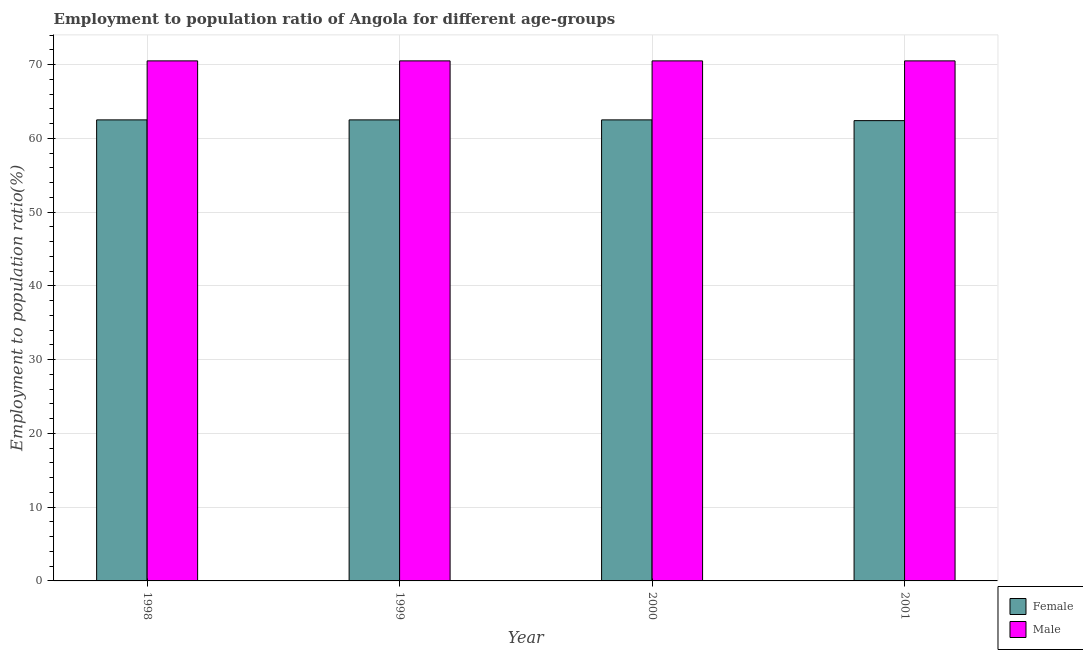How many different coloured bars are there?
Your response must be concise. 2. Are the number of bars per tick equal to the number of legend labels?
Ensure brevity in your answer.  Yes. Are the number of bars on each tick of the X-axis equal?
Your answer should be compact. Yes. How many bars are there on the 1st tick from the left?
Offer a very short reply. 2. What is the employment to population ratio(female) in 1998?
Provide a short and direct response. 62.5. Across all years, what is the maximum employment to population ratio(male)?
Ensure brevity in your answer.  70.5. Across all years, what is the minimum employment to population ratio(female)?
Keep it short and to the point. 62.4. In which year was the employment to population ratio(male) maximum?
Ensure brevity in your answer.  1998. In which year was the employment to population ratio(female) minimum?
Keep it short and to the point. 2001. What is the total employment to population ratio(male) in the graph?
Keep it short and to the point. 282. What is the difference between the employment to population ratio(female) in 1998 and that in 2001?
Provide a short and direct response. 0.1. What is the difference between the employment to population ratio(male) in 1998 and the employment to population ratio(female) in 2000?
Provide a short and direct response. 0. What is the average employment to population ratio(female) per year?
Offer a very short reply. 62.48. What is the ratio of the employment to population ratio(male) in 2000 to that in 2001?
Offer a very short reply. 1. Is the employment to population ratio(male) in 1998 less than that in 2000?
Provide a succinct answer. No. Is the difference between the employment to population ratio(male) in 1998 and 2000 greater than the difference between the employment to population ratio(female) in 1998 and 2000?
Keep it short and to the point. No. In how many years, is the employment to population ratio(female) greater than the average employment to population ratio(female) taken over all years?
Provide a short and direct response. 3. How many bars are there?
Keep it short and to the point. 8. How many years are there in the graph?
Your response must be concise. 4. Does the graph contain grids?
Your response must be concise. Yes. How many legend labels are there?
Give a very brief answer. 2. What is the title of the graph?
Your answer should be compact. Employment to population ratio of Angola for different age-groups. What is the Employment to population ratio(%) of Female in 1998?
Ensure brevity in your answer.  62.5. What is the Employment to population ratio(%) of Male in 1998?
Provide a short and direct response. 70.5. What is the Employment to population ratio(%) of Female in 1999?
Make the answer very short. 62.5. What is the Employment to population ratio(%) in Male in 1999?
Offer a very short reply. 70.5. What is the Employment to population ratio(%) of Female in 2000?
Give a very brief answer. 62.5. What is the Employment to population ratio(%) in Male in 2000?
Ensure brevity in your answer.  70.5. What is the Employment to population ratio(%) of Female in 2001?
Make the answer very short. 62.4. What is the Employment to population ratio(%) of Male in 2001?
Give a very brief answer. 70.5. Across all years, what is the maximum Employment to population ratio(%) in Female?
Provide a succinct answer. 62.5. Across all years, what is the maximum Employment to population ratio(%) of Male?
Give a very brief answer. 70.5. Across all years, what is the minimum Employment to population ratio(%) of Female?
Offer a terse response. 62.4. Across all years, what is the minimum Employment to population ratio(%) of Male?
Provide a short and direct response. 70.5. What is the total Employment to population ratio(%) in Female in the graph?
Offer a terse response. 249.9. What is the total Employment to population ratio(%) of Male in the graph?
Your response must be concise. 282. What is the difference between the Employment to population ratio(%) of Female in 1998 and that in 1999?
Give a very brief answer. 0. What is the difference between the Employment to population ratio(%) in Male in 1998 and that in 1999?
Keep it short and to the point. 0. What is the difference between the Employment to population ratio(%) in Female in 1998 and that in 2001?
Offer a very short reply. 0.1. What is the difference between the Employment to population ratio(%) of Female in 1999 and that in 2000?
Give a very brief answer. 0. What is the difference between the Employment to population ratio(%) of Female in 1999 and that in 2001?
Ensure brevity in your answer.  0.1. What is the difference between the Employment to population ratio(%) of Male in 1999 and that in 2001?
Provide a short and direct response. 0. What is the difference between the Employment to population ratio(%) in Male in 2000 and that in 2001?
Ensure brevity in your answer.  0. What is the difference between the Employment to population ratio(%) in Female in 1998 and the Employment to population ratio(%) in Male in 2001?
Ensure brevity in your answer.  -8. What is the difference between the Employment to population ratio(%) in Female in 1999 and the Employment to population ratio(%) in Male in 2000?
Provide a short and direct response. -8. What is the difference between the Employment to population ratio(%) in Female in 1999 and the Employment to population ratio(%) in Male in 2001?
Keep it short and to the point. -8. What is the difference between the Employment to population ratio(%) of Female in 2000 and the Employment to population ratio(%) of Male in 2001?
Provide a short and direct response. -8. What is the average Employment to population ratio(%) in Female per year?
Ensure brevity in your answer.  62.48. What is the average Employment to population ratio(%) in Male per year?
Your answer should be very brief. 70.5. In the year 1998, what is the difference between the Employment to population ratio(%) in Female and Employment to population ratio(%) in Male?
Make the answer very short. -8. In the year 1999, what is the difference between the Employment to population ratio(%) in Female and Employment to population ratio(%) in Male?
Make the answer very short. -8. In the year 2001, what is the difference between the Employment to population ratio(%) of Female and Employment to population ratio(%) of Male?
Your response must be concise. -8.1. What is the ratio of the Employment to population ratio(%) of Female in 1998 to that in 1999?
Ensure brevity in your answer.  1. What is the ratio of the Employment to population ratio(%) in Male in 1998 to that in 1999?
Ensure brevity in your answer.  1. What is the ratio of the Employment to population ratio(%) of Female in 1998 to that in 2001?
Offer a terse response. 1. What is the ratio of the Employment to population ratio(%) of Male in 1999 to that in 2000?
Offer a terse response. 1. What is the ratio of the Employment to population ratio(%) in Female in 1999 to that in 2001?
Make the answer very short. 1. What is the difference between the highest and the second highest Employment to population ratio(%) in Male?
Keep it short and to the point. 0. What is the difference between the highest and the lowest Employment to population ratio(%) in Female?
Give a very brief answer. 0.1. What is the difference between the highest and the lowest Employment to population ratio(%) in Male?
Ensure brevity in your answer.  0. 